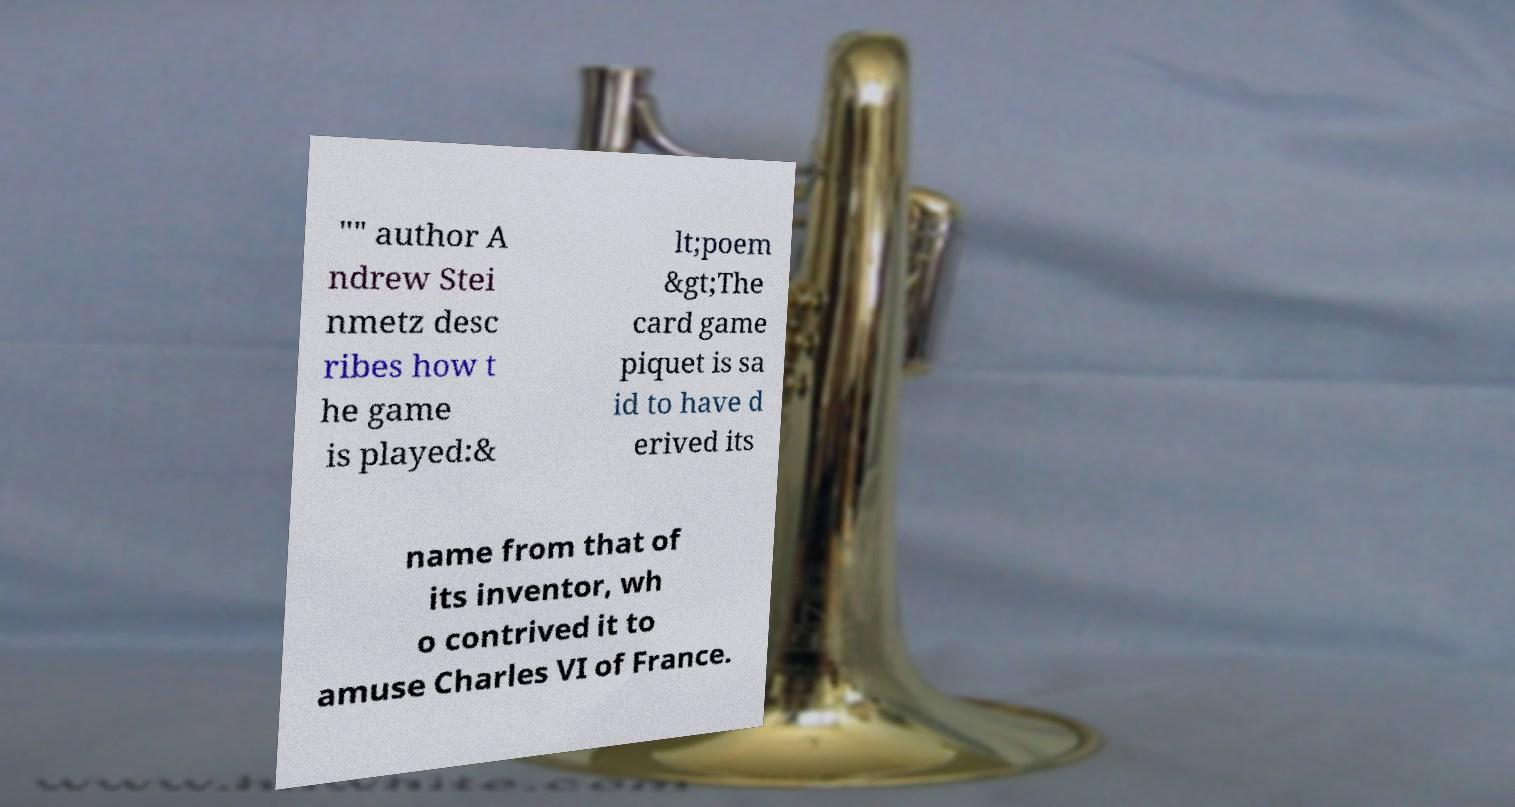I need the written content from this picture converted into text. Can you do that? "" author A ndrew Stei nmetz desc ribes how t he game is played:& lt;poem &gt;The card game piquet is sa id to have d erived its name from that of its inventor, wh o contrived it to amuse Charles VI of France. 